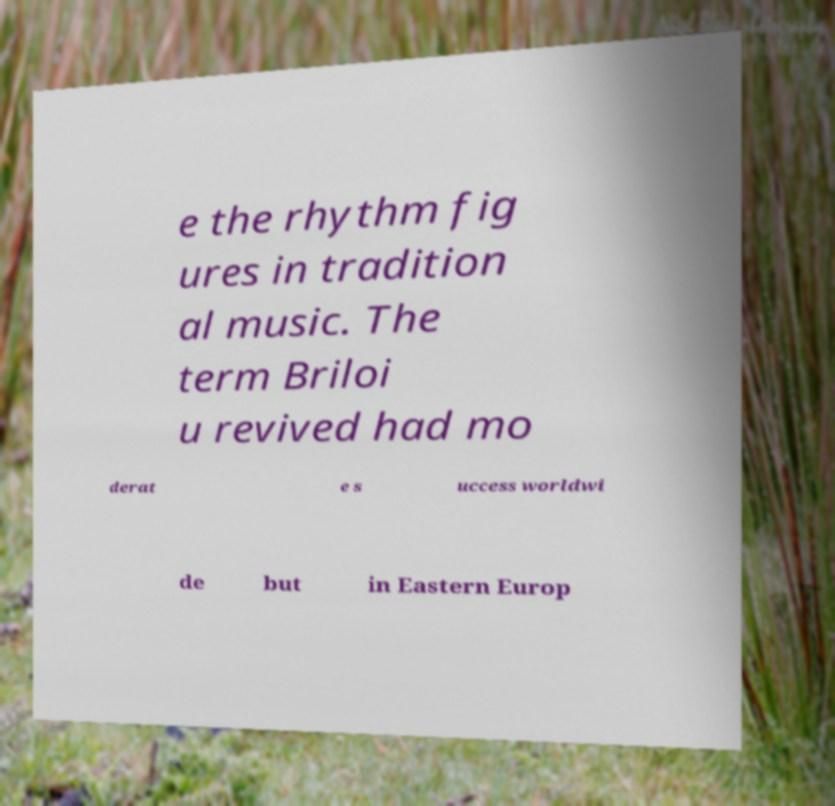Can you read and provide the text displayed in the image?This photo seems to have some interesting text. Can you extract and type it out for me? e the rhythm fig ures in tradition al music. The term Briloi u revived had mo derat e s uccess worldwi de but in Eastern Europ 